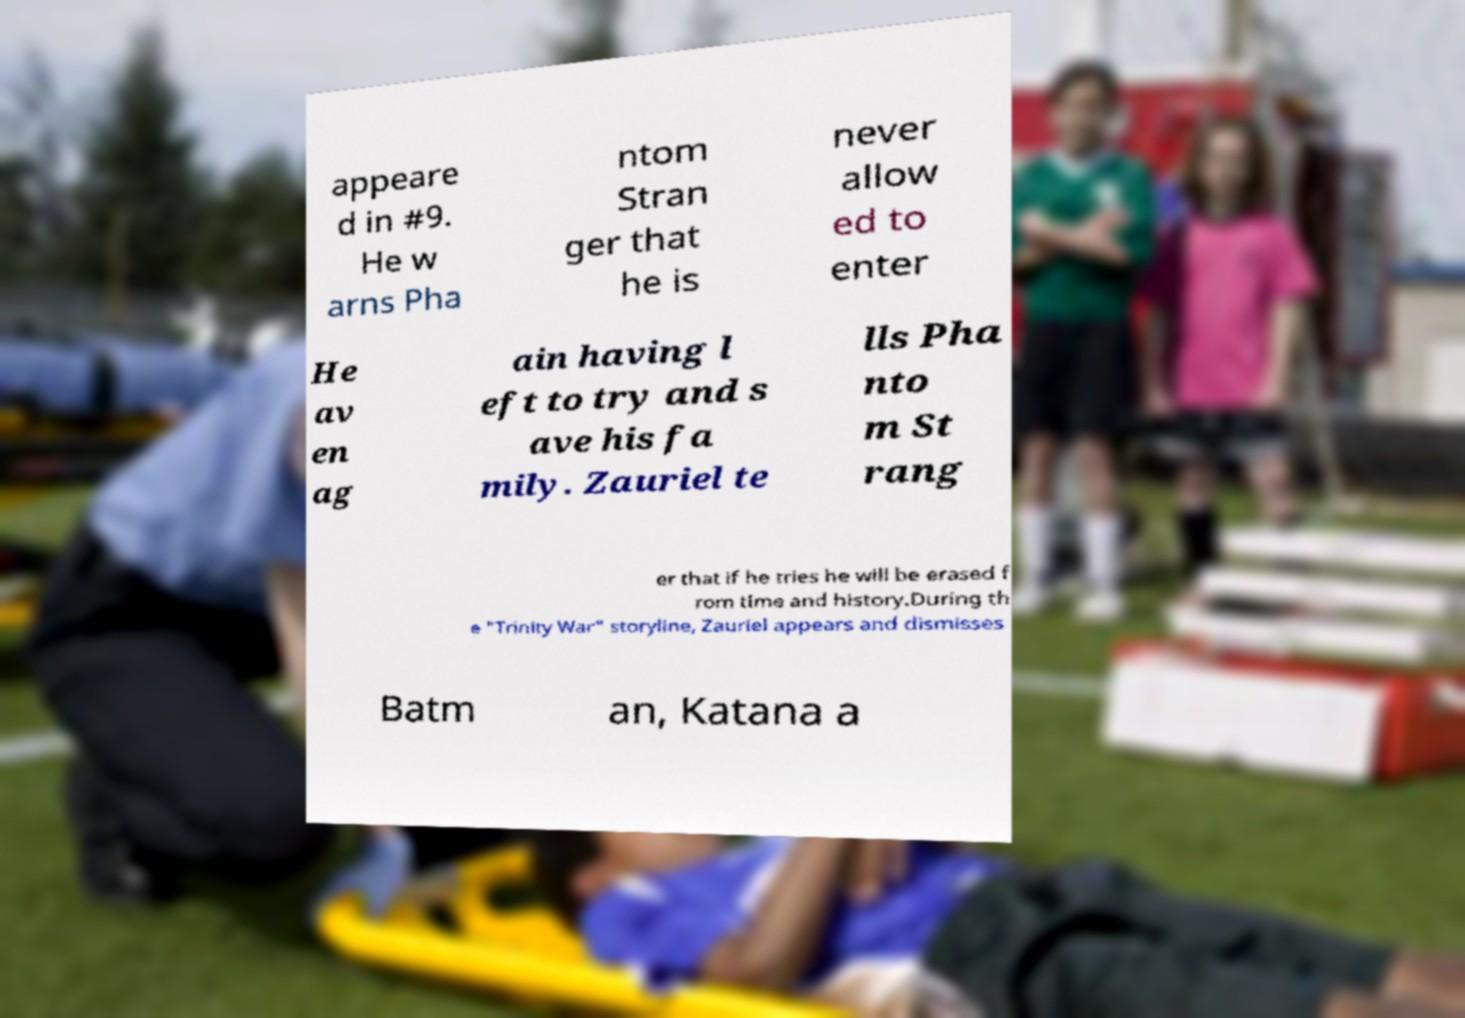Can you accurately transcribe the text from the provided image for me? appeare d in #9. He w arns Pha ntom Stran ger that he is never allow ed to enter He av en ag ain having l eft to try and s ave his fa mily. Zauriel te lls Pha nto m St rang er that if he tries he will be erased f rom time and history.During th e "Trinity War" storyline, Zauriel appears and dismisses Batm an, Katana a 